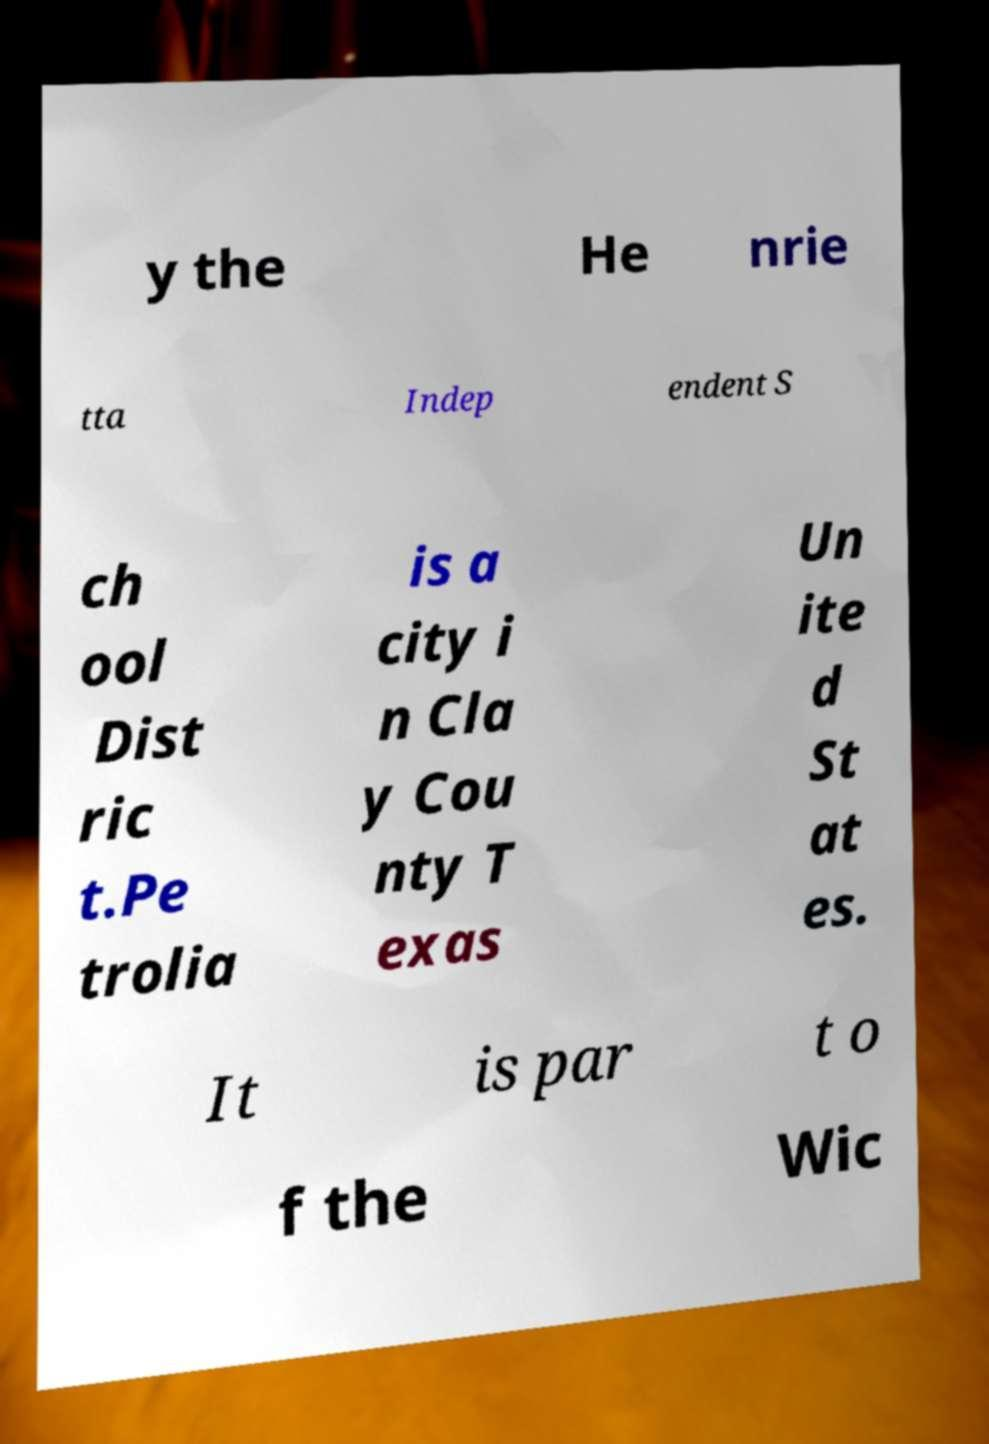For documentation purposes, I need the text within this image transcribed. Could you provide that? y the He nrie tta Indep endent S ch ool Dist ric t.Pe trolia is a city i n Cla y Cou nty T exas Un ite d St at es. It is par t o f the Wic 